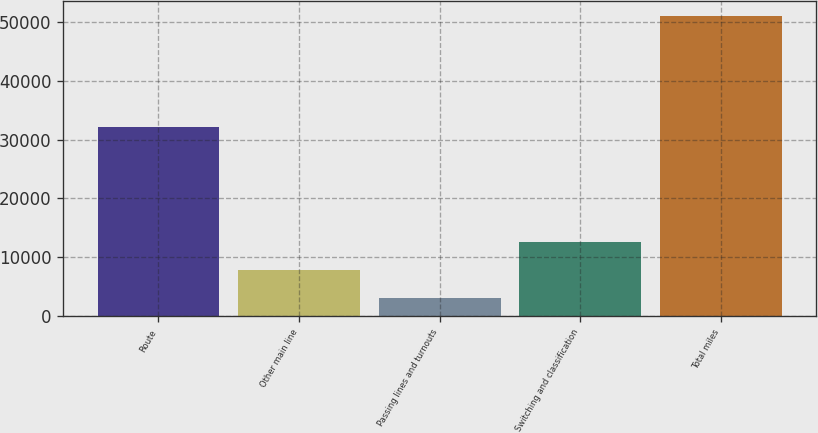Convert chart. <chart><loc_0><loc_0><loc_500><loc_500><bar_chart><fcel>Route<fcel>Other main line<fcel>Passing lines and turnouts<fcel>Switching and classification<fcel>Total miles<nl><fcel>32094<fcel>7824.5<fcel>3040<fcel>12609<fcel>50885<nl></chart> 